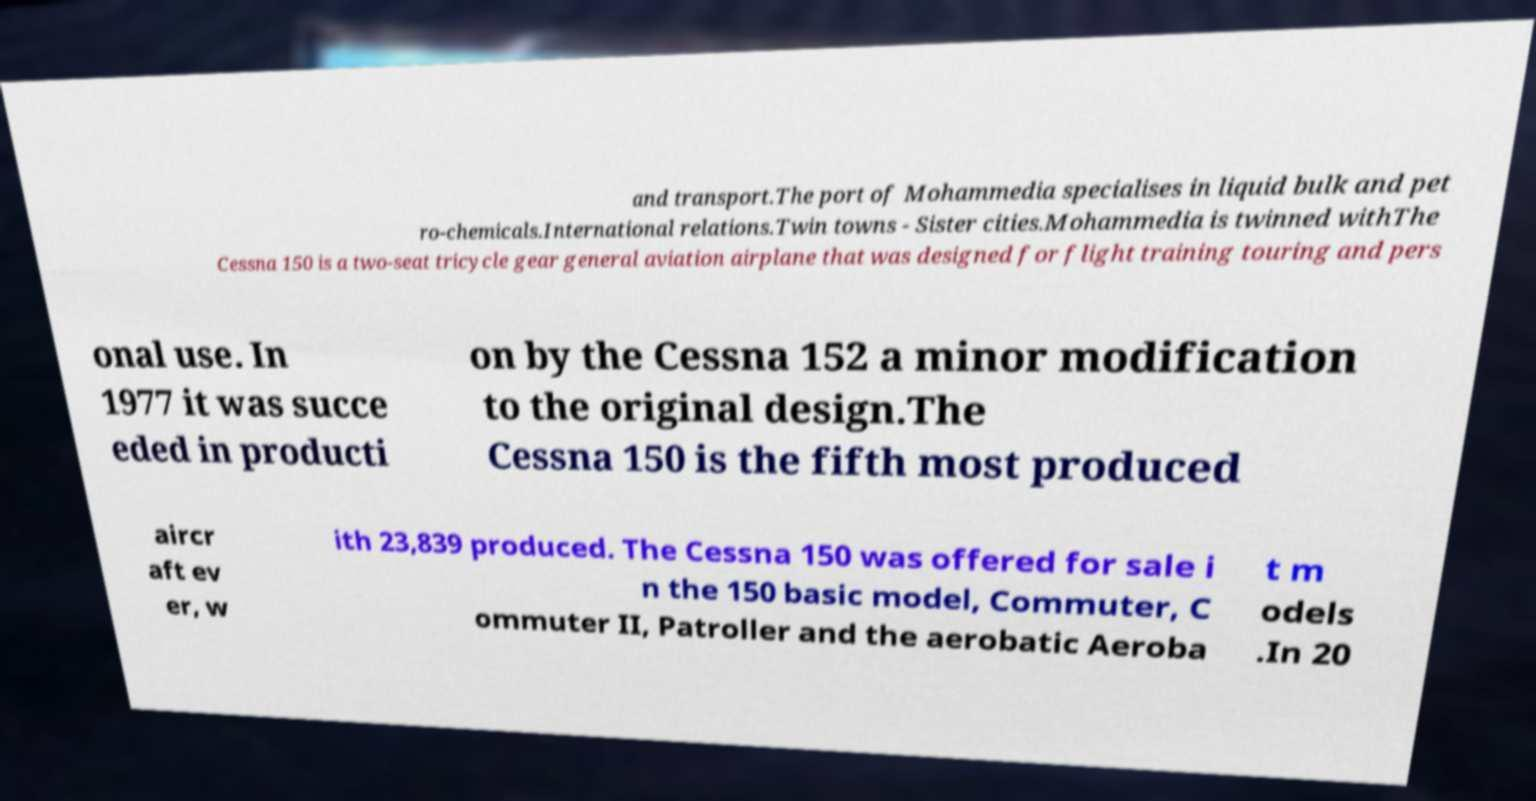What messages or text are displayed in this image? I need them in a readable, typed format. and transport.The port of Mohammedia specialises in liquid bulk and pet ro-chemicals.International relations.Twin towns - Sister cities.Mohammedia is twinned withThe Cessna 150 is a two-seat tricycle gear general aviation airplane that was designed for flight training touring and pers onal use. In 1977 it was succe eded in producti on by the Cessna 152 a minor modification to the original design.The Cessna 150 is the fifth most produced aircr aft ev er, w ith 23,839 produced. The Cessna 150 was offered for sale i n the 150 basic model, Commuter, C ommuter II, Patroller and the aerobatic Aeroba t m odels .In 20 